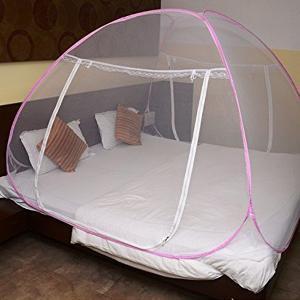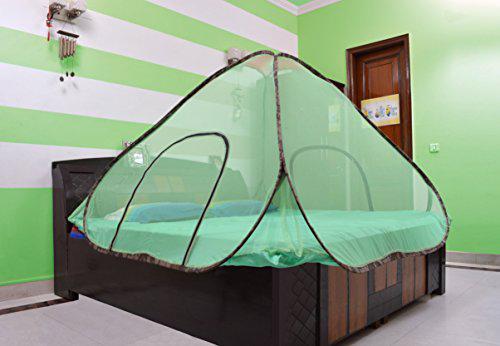The first image is the image on the left, the second image is the image on the right. Considering the images on both sides, is "In each image, an igloo-shaped net cover is positioned over a double bed with brown and white pillows." valid? Answer yes or no. No. 